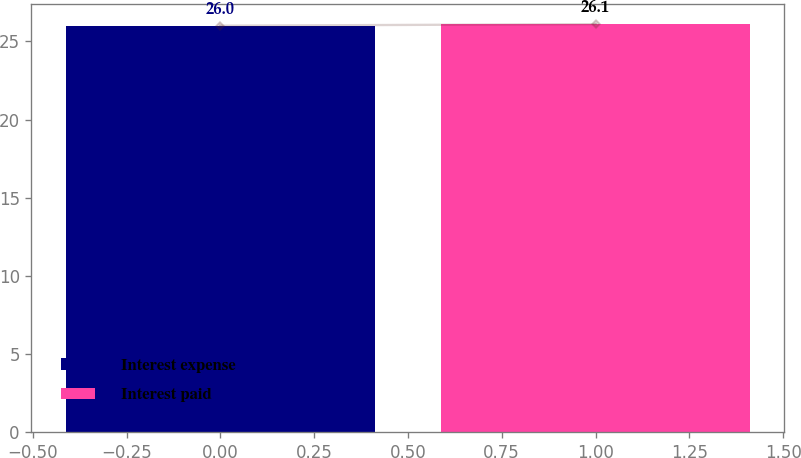<chart> <loc_0><loc_0><loc_500><loc_500><bar_chart><fcel>Interest expense<fcel>Interest paid<nl><fcel>26<fcel>26.1<nl></chart> 